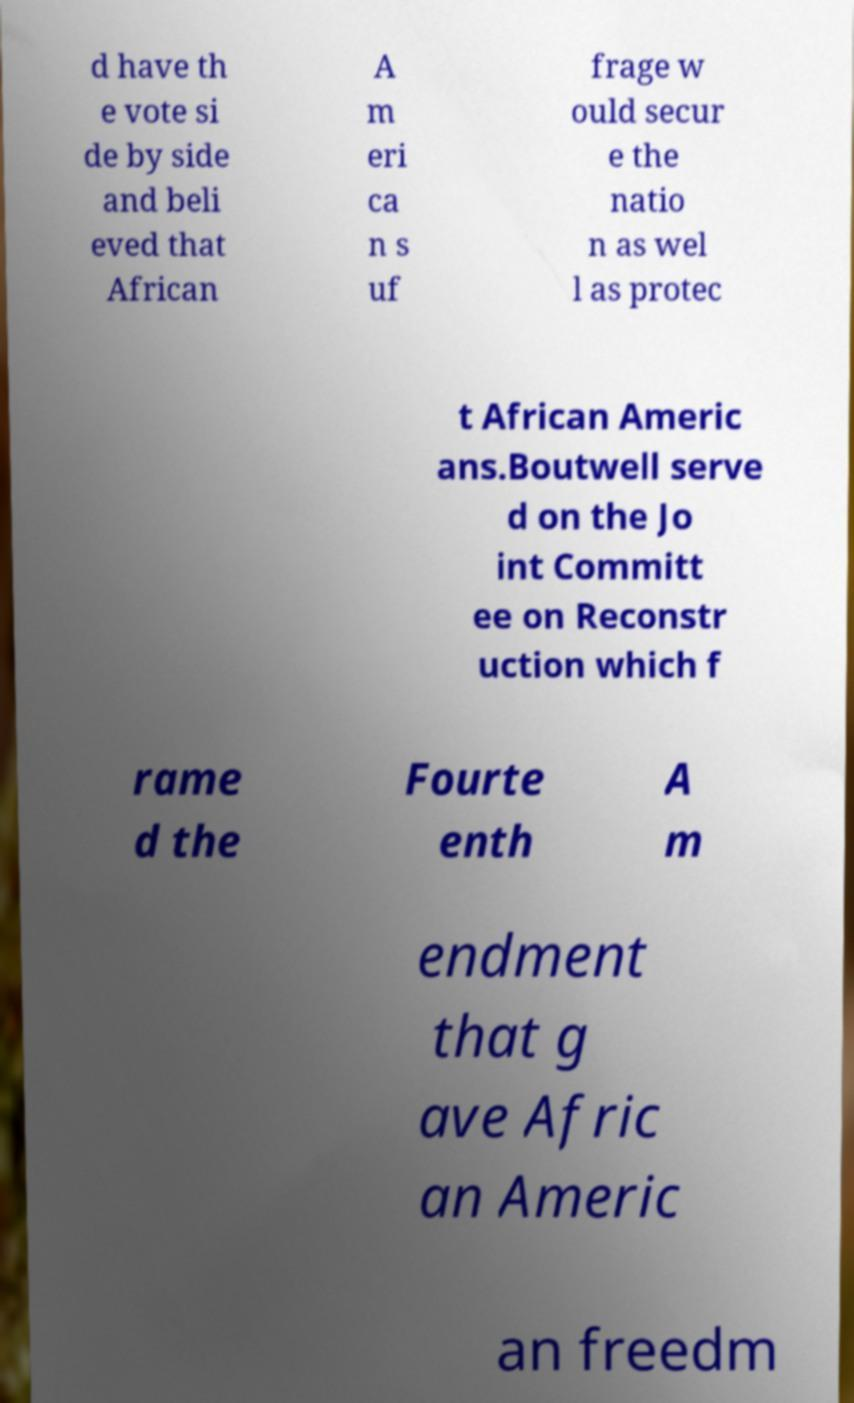Can you accurately transcribe the text from the provided image for me? d have th e vote si de by side and beli eved that African A m eri ca n s uf frage w ould secur e the natio n as wel l as protec t African Americ ans.Boutwell serve d on the Jo int Committ ee on Reconstr uction which f rame d the Fourte enth A m endment that g ave Afric an Americ an freedm 